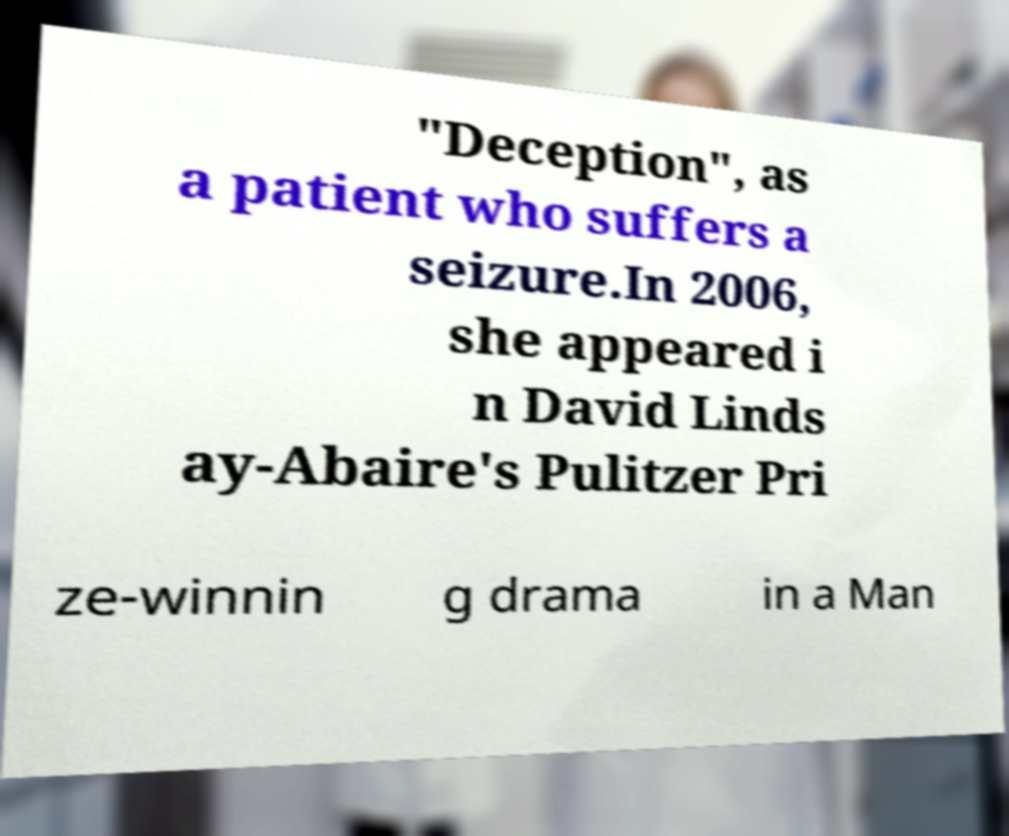Please identify and transcribe the text found in this image. "Deception", as a patient who suffers a seizure.In 2006, she appeared i n David Linds ay-Abaire's Pulitzer Pri ze-winnin g drama in a Man 